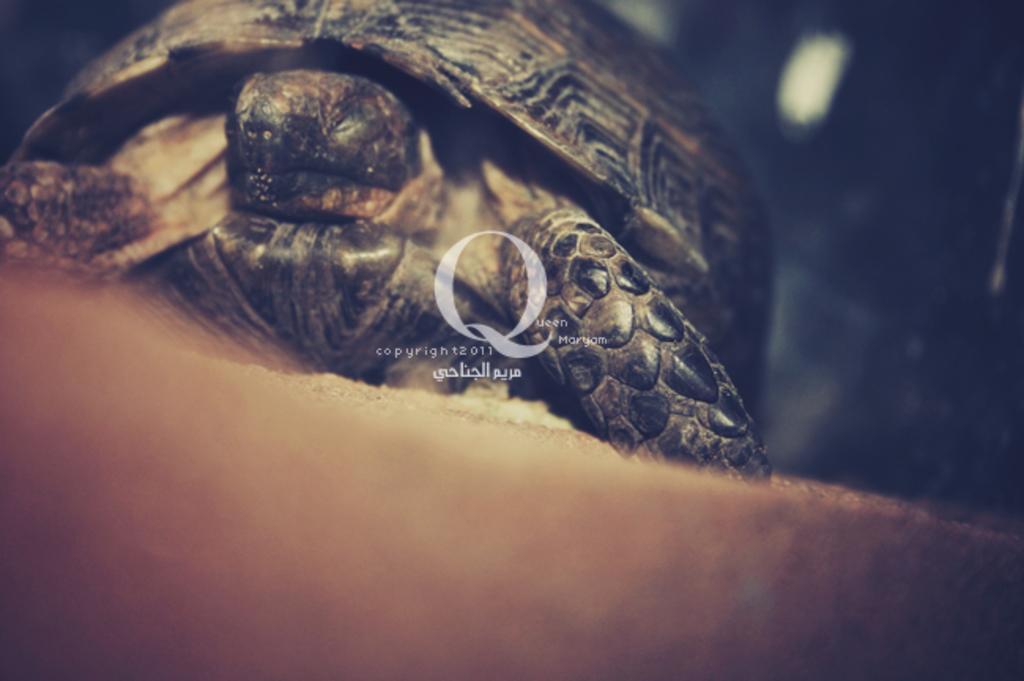Can you describe this image briefly? In this image I can see a tortoise which is brown, black and cream in color. I can see the black colored background. 